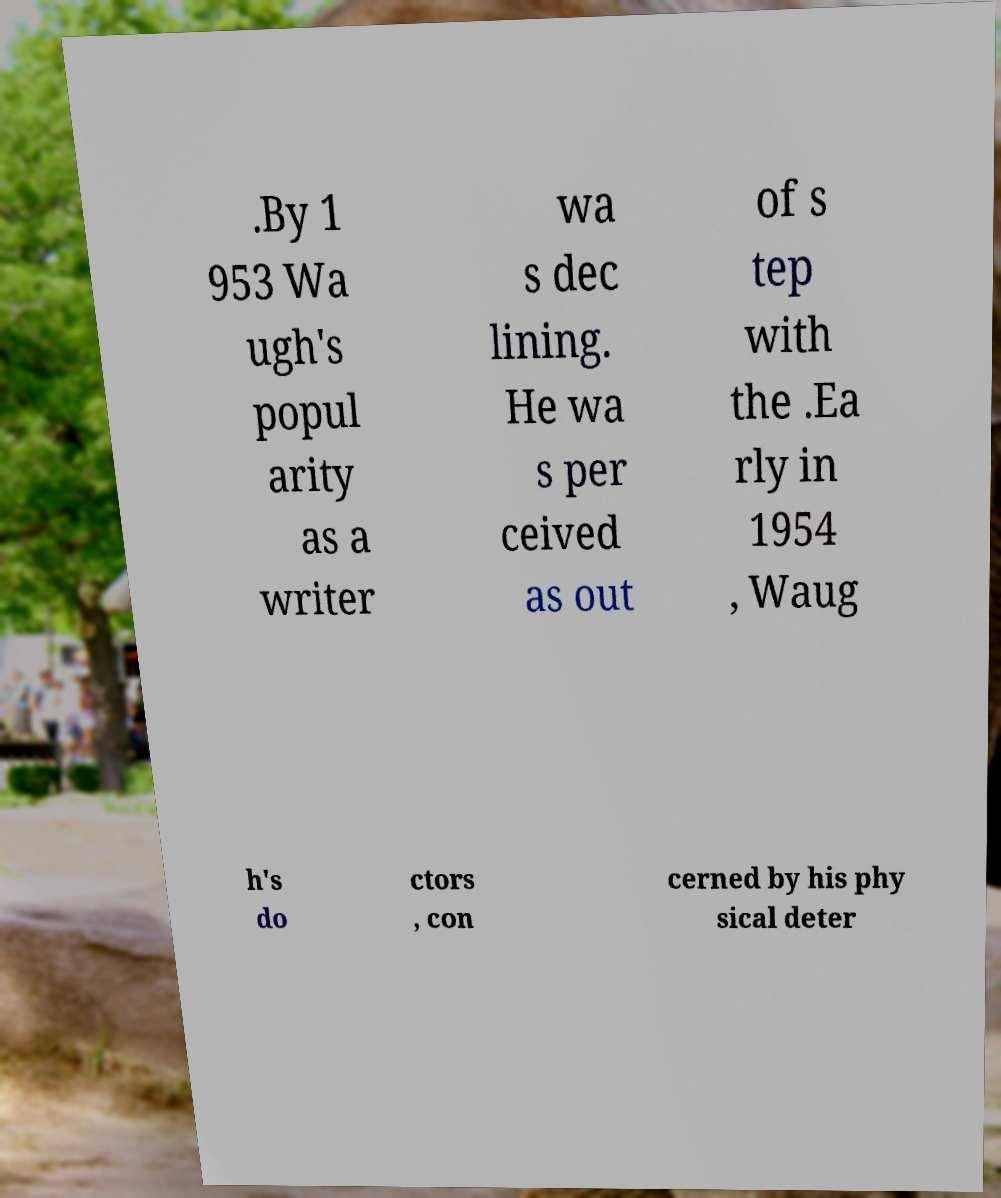Could you extract and type out the text from this image? .By 1 953 Wa ugh's popul arity as a writer wa s dec lining. He wa s per ceived as out of s tep with the .Ea rly in 1954 , Waug h's do ctors , con cerned by his phy sical deter 